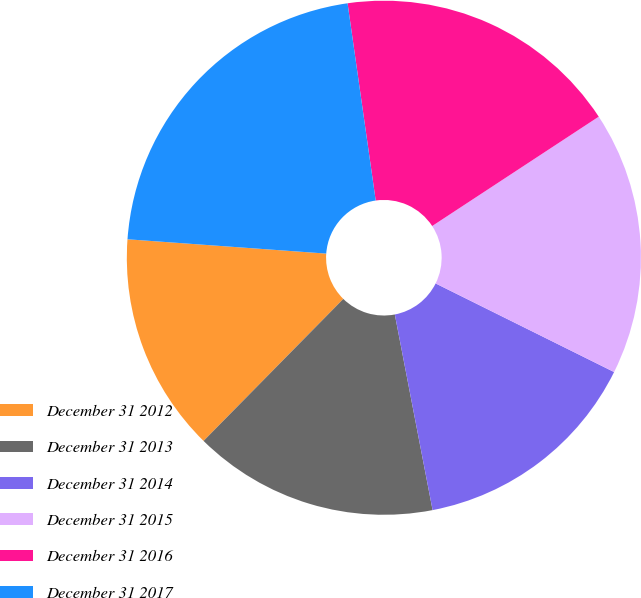Convert chart to OTSL. <chart><loc_0><loc_0><loc_500><loc_500><pie_chart><fcel>December 31 2012<fcel>December 31 2013<fcel>December 31 2014<fcel>December 31 2015<fcel>December 31 2016<fcel>December 31 2017<nl><fcel>13.77%<fcel>15.41%<fcel>14.63%<fcel>16.58%<fcel>18.01%<fcel>21.6%<nl></chart> 